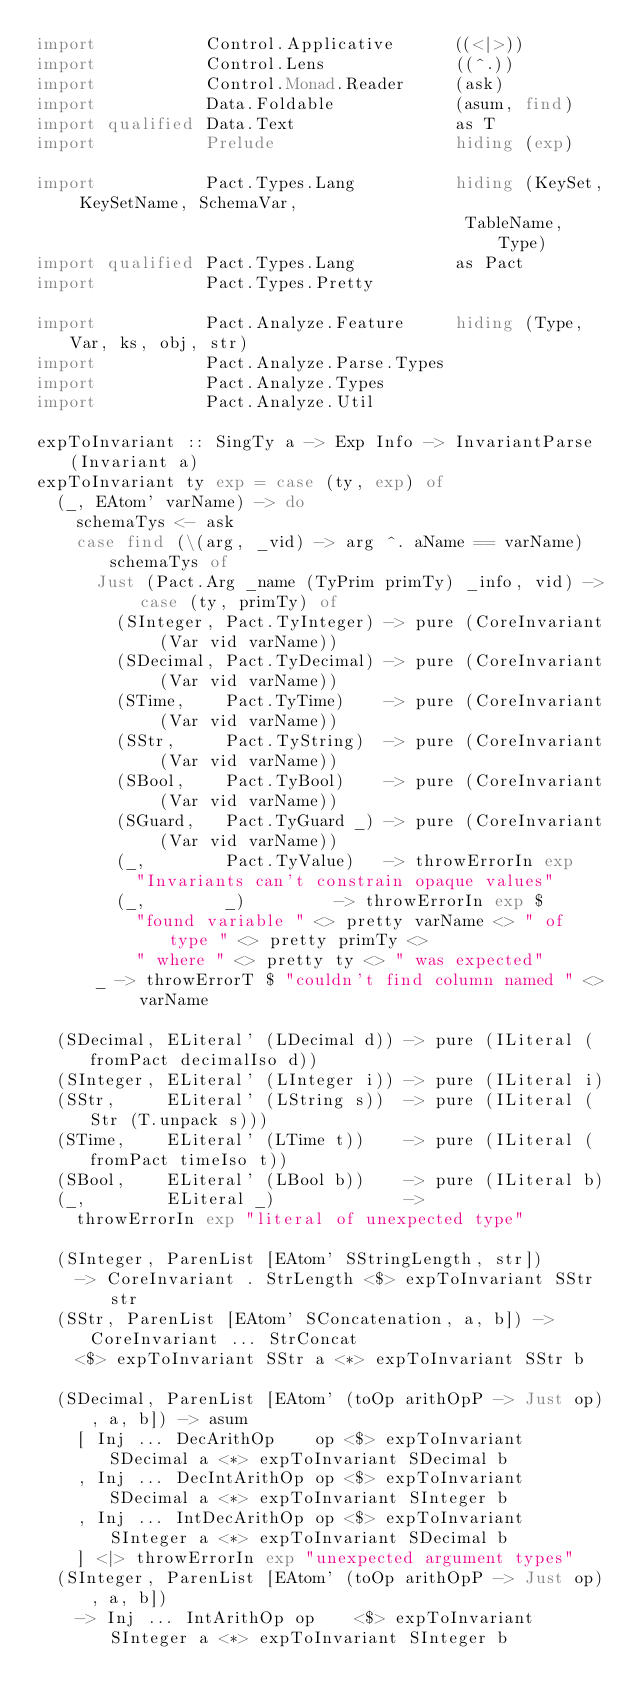Convert code to text. <code><loc_0><loc_0><loc_500><loc_500><_Haskell_>import           Control.Applicative      ((<|>))
import           Control.Lens             ((^.))
import           Control.Monad.Reader     (ask)
import           Data.Foldable            (asum, find)
import qualified Data.Text                as T
import           Prelude                  hiding (exp)

import           Pact.Types.Lang          hiding (KeySet, KeySetName, SchemaVar,
                                           TableName, Type)
import qualified Pact.Types.Lang          as Pact
import           Pact.Types.Pretty

import           Pact.Analyze.Feature     hiding (Type, Var, ks, obj, str)
import           Pact.Analyze.Parse.Types
import           Pact.Analyze.Types
import           Pact.Analyze.Util

expToInvariant :: SingTy a -> Exp Info -> InvariantParse (Invariant a)
expToInvariant ty exp = case (ty, exp) of
  (_, EAtom' varName) -> do
    schemaTys <- ask
    case find (\(arg, _vid) -> arg ^. aName == varName) schemaTys of
      Just (Pact.Arg _name (TyPrim primTy) _info, vid) -> case (ty, primTy) of
        (SInteger, Pact.TyInteger) -> pure (CoreInvariant (Var vid varName))
        (SDecimal, Pact.TyDecimal) -> pure (CoreInvariant (Var vid varName))
        (STime,    Pact.TyTime)    -> pure (CoreInvariant (Var vid varName))
        (SStr,     Pact.TyString)  -> pure (CoreInvariant (Var vid varName))
        (SBool,    Pact.TyBool)    -> pure (CoreInvariant (Var vid varName))
        (SGuard,   Pact.TyGuard _) -> pure (CoreInvariant (Var vid varName))
        (_,        Pact.TyValue)   -> throwErrorIn exp
          "Invariants can't constrain opaque values"
        (_,        _)         -> throwErrorIn exp $
          "found variable " <> pretty varName <> " of type " <> pretty primTy <>
          " where " <> pretty ty <> " was expected"
      _ -> throwErrorT $ "couldn't find column named " <> varName

  (SDecimal, ELiteral' (LDecimal d)) -> pure (ILiteral (fromPact decimalIso d))
  (SInteger, ELiteral' (LInteger i)) -> pure (ILiteral i)
  (SStr,     ELiteral' (LString s))  -> pure (ILiteral (Str (T.unpack s)))
  (STime,    ELiteral' (LTime t))    -> pure (ILiteral (fromPact timeIso t))
  (SBool,    ELiteral' (LBool b))    -> pure (ILiteral b)
  (_,        ELiteral _)             ->
    throwErrorIn exp "literal of unexpected type"

  (SInteger, ParenList [EAtom' SStringLength, str])
    -> CoreInvariant . StrLength <$> expToInvariant SStr str
  (SStr, ParenList [EAtom' SConcatenation, a, b]) -> CoreInvariant ... StrConcat
    <$> expToInvariant SStr a <*> expToInvariant SStr b

  (SDecimal, ParenList [EAtom' (toOp arithOpP -> Just op), a, b]) -> asum
    [ Inj ... DecArithOp    op <$> expToInvariant SDecimal a <*> expToInvariant SDecimal b
    , Inj ... DecIntArithOp op <$> expToInvariant SDecimal a <*> expToInvariant SInteger b
    , Inj ... IntDecArithOp op <$> expToInvariant SInteger a <*> expToInvariant SDecimal b
    ] <|> throwErrorIn exp "unexpected argument types"
  (SInteger, ParenList [EAtom' (toOp arithOpP -> Just op), a, b])
    -> Inj ... IntArithOp op    <$> expToInvariant SInteger a <*> expToInvariant SInteger b</code> 